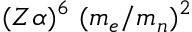Convert formula to latex. <formula><loc_0><loc_0><loc_500><loc_500>( Z \alpha ) ^ { 6 } ( m _ { e } / m _ { n } ) ^ { 2 }</formula> 